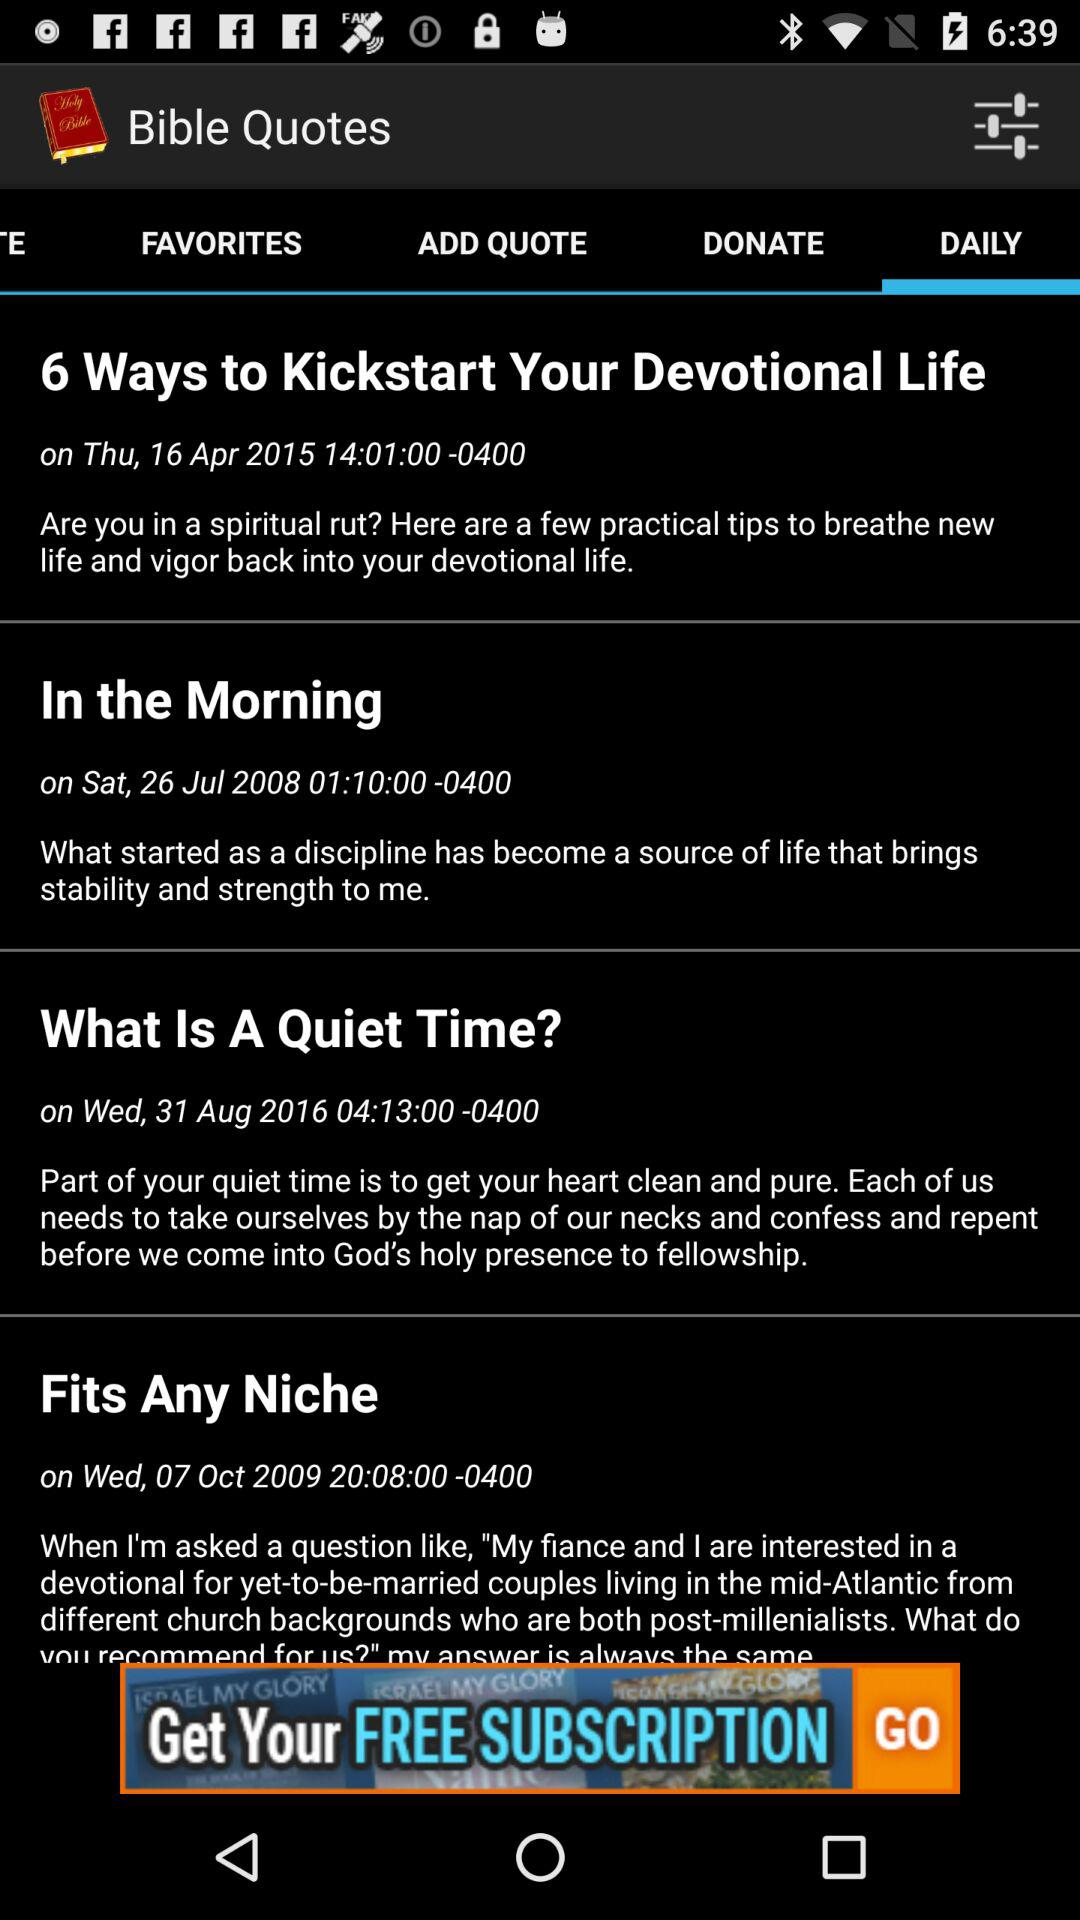Which tab is selected? The selected tab is "DAILY". 